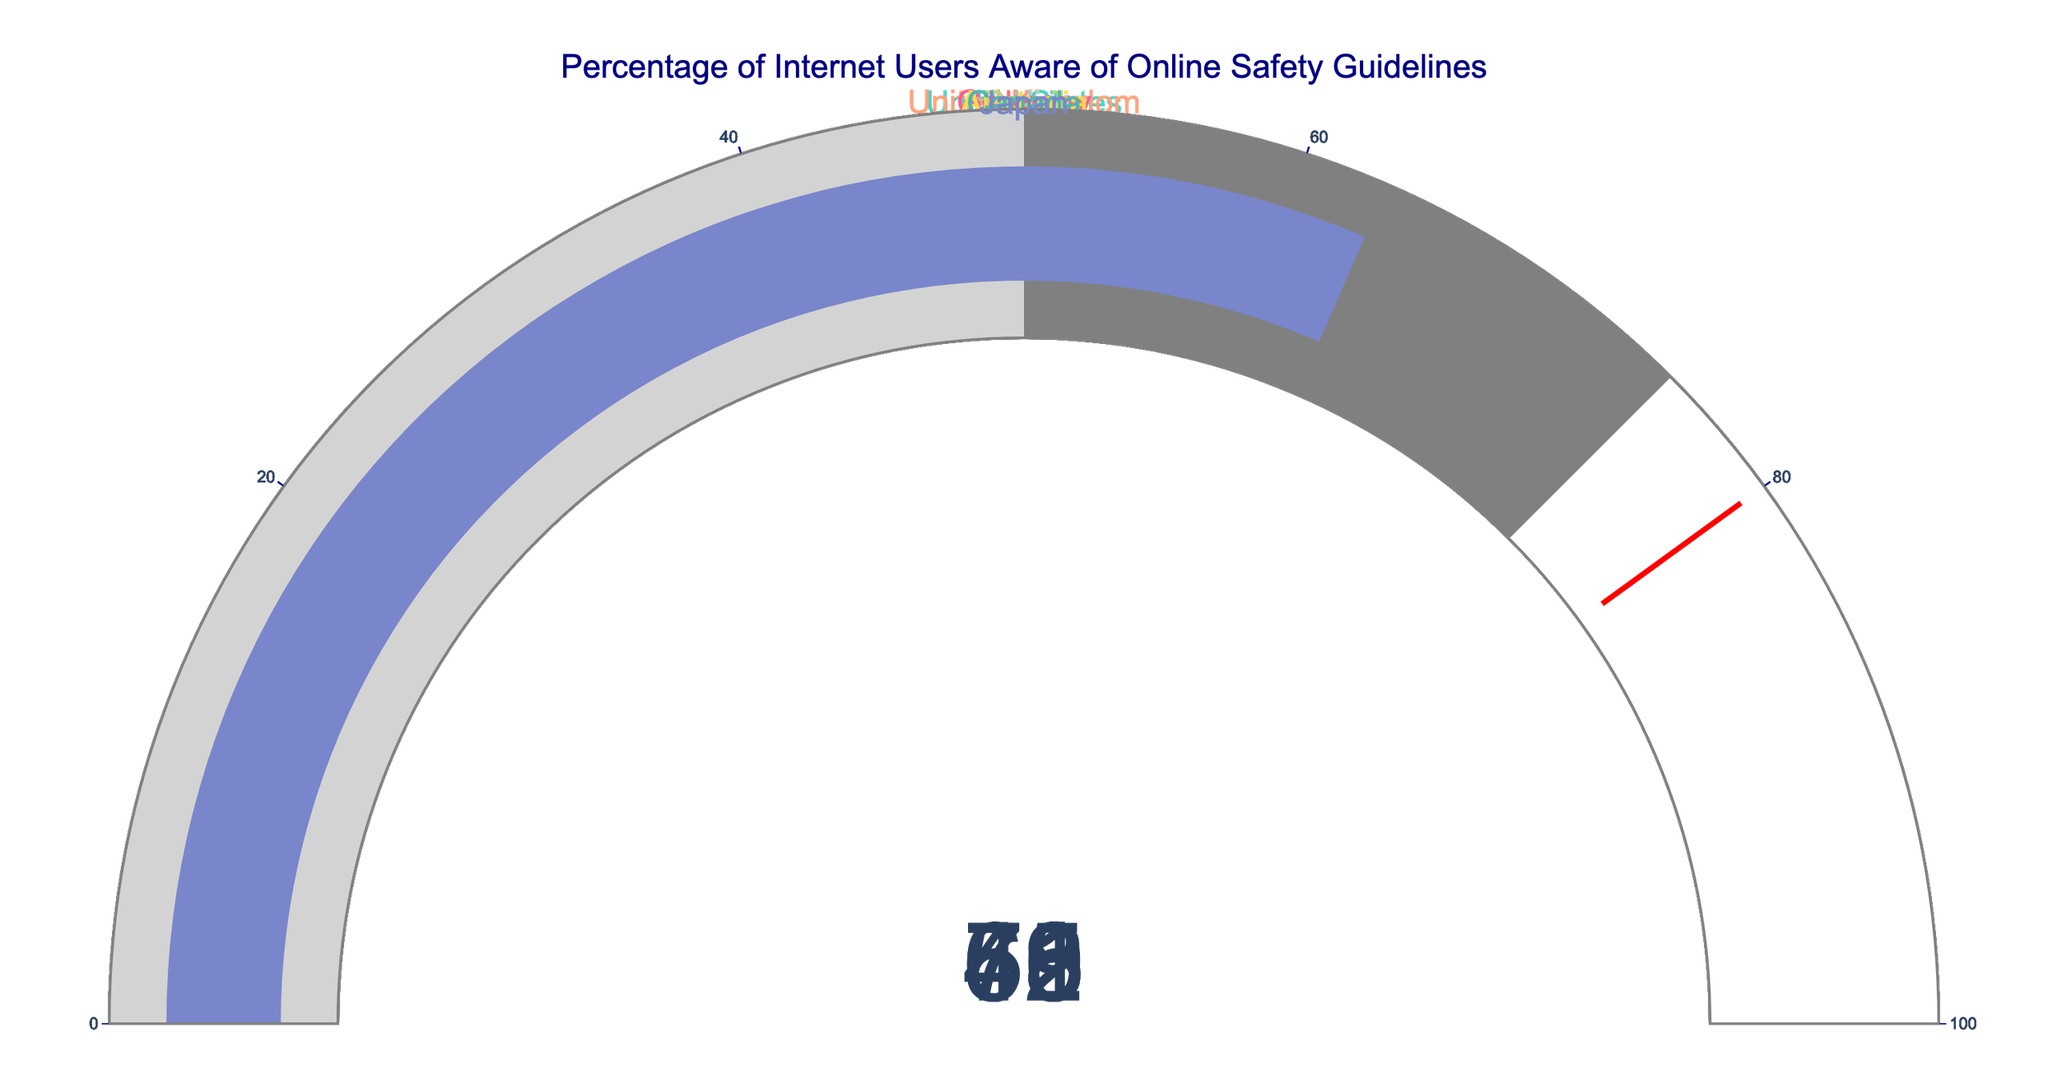What is the highest percentage of internet users aware of online safety guidelines among the listed countries? By looking at the individual gauges, we identify the country with the highest value. The gauges indicate that China has the highest percentage at 78%
Answer: 78% What is the lowest percentage of internet users aware of online safety guidelines among the listed countries? By reviewing each gauge on the chart, we see that India has the lowest awareness percentage at 45%
Answer: 45% How many countries have an awareness percentage greater than 70%? By inspecting each gauge, we count the number of countries with values above 70%. China (78%), United Kingdom (72%), Germany (70%), and Canada (71%) make four countries in total
Answer: 4 Which countries have an awareness percentage between 60% and 70%? We identify the countries within this range by checking the gauges. The countries are United States (65%), Japan (63%), and Australia (68%)
Answer: United States, Japan, Australia What is the average awareness percentage of online safety guidelines for all listed countries? We need to calculate the sum of the percentages and divide by the number of countries. The sum is 78 + 65 + 59 + 72 + 45 + 70 + 52 + 68 + 71 + 63 = 643. There are 10 countries, so 643/10 gives an average of 64.3%
Answer: 64.3% Which country has an awareness percentage closest to the average value? From the previous question, the average is 64.3%. We compare each country's value to this average. Japan has an awareness percentage of 63%, which is closest to 64.3%
Answer: Japan Calculate the difference in awareness percentage between the highest and lowest countries. The highest percentage is 78% (China), and the lowest is 45% (India). The difference is 78 - 45 = 33
Answer: 33 Which countries fall within the 50%-75% awareness range? By checking the gauges, the countries within this range are United States (65%), Russia (59%), United Kingdom (72%), Germany (70%), Brazil (52%), Australia (68%), Canada (71%), and Japan (63%)
Answer: United States, Russia, United Kingdom, Germany, Brazil, Australia, Canada, Japan How many countries have an awareness percentage below the global average of 50%? By comparing each gauge to the threshold of 50%, we find that only India at 45% falls below this threshold
Answer: 1 Which country has a value of 59%? By looking at the gauge with the value of 59%, we identify Russia
Answer: Russia 